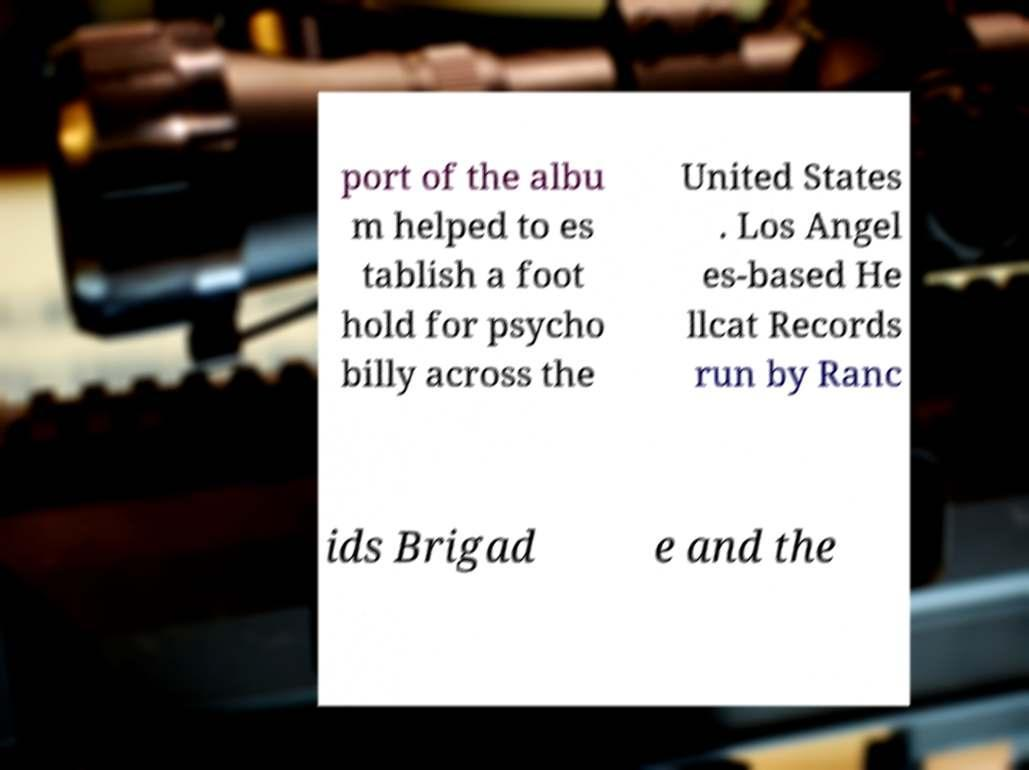Please identify and transcribe the text found in this image. port of the albu m helped to es tablish a foot hold for psycho billy across the United States . Los Angel es-based He llcat Records run by Ranc ids Brigad e and the 